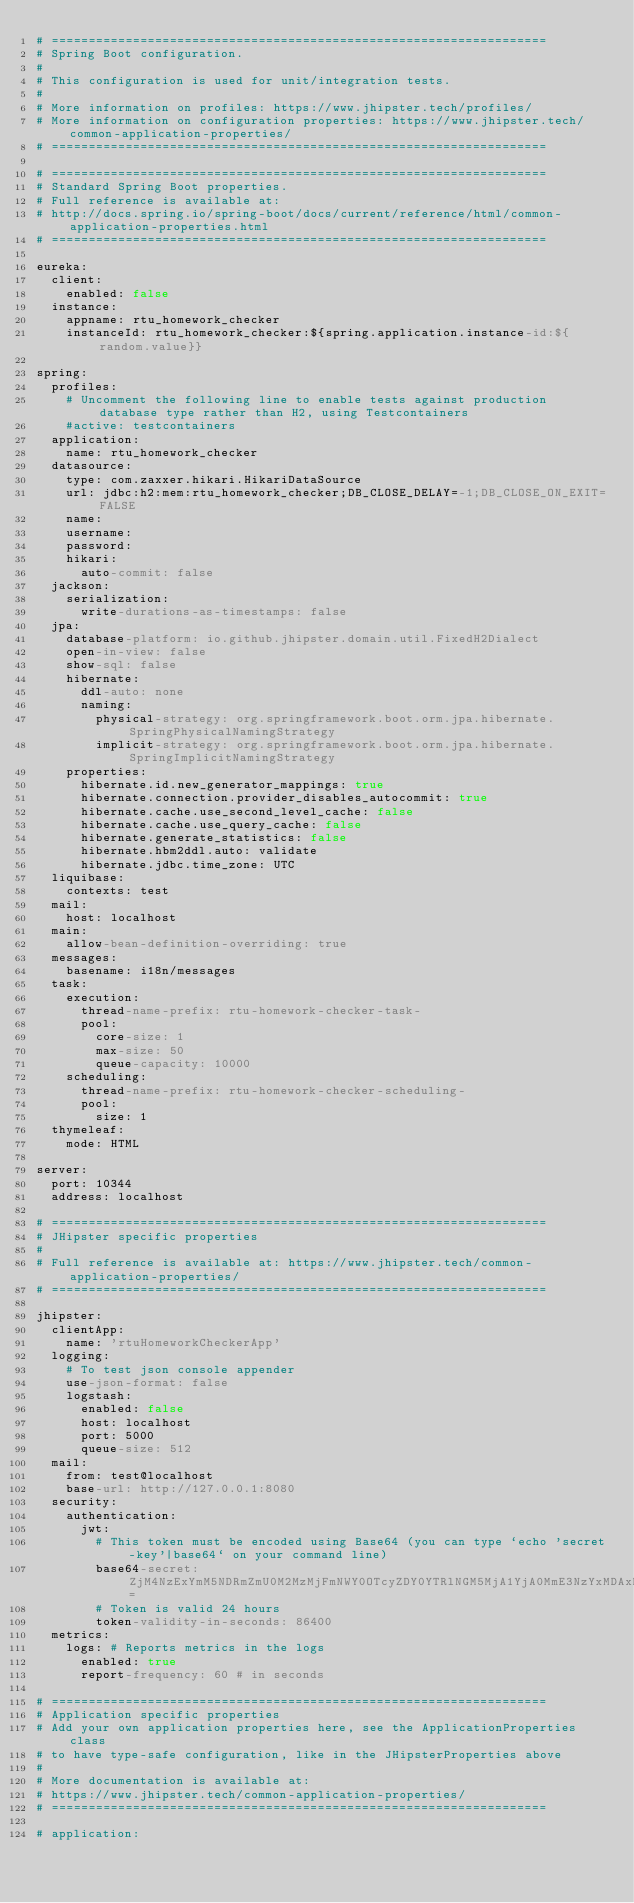<code> <loc_0><loc_0><loc_500><loc_500><_YAML_># ===================================================================
# Spring Boot configuration.
#
# This configuration is used for unit/integration tests.
#
# More information on profiles: https://www.jhipster.tech/profiles/
# More information on configuration properties: https://www.jhipster.tech/common-application-properties/
# ===================================================================

# ===================================================================
# Standard Spring Boot properties.
# Full reference is available at:
# http://docs.spring.io/spring-boot/docs/current/reference/html/common-application-properties.html
# ===================================================================

eureka:
  client:
    enabled: false
  instance:
    appname: rtu_homework_checker
    instanceId: rtu_homework_checker:${spring.application.instance-id:${random.value}}

spring:
  profiles:
    # Uncomment the following line to enable tests against production database type rather than H2, using Testcontainers
    #active: testcontainers
  application:
    name: rtu_homework_checker
  datasource:
    type: com.zaxxer.hikari.HikariDataSource
    url: jdbc:h2:mem:rtu_homework_checker;DB_CLOSE_DELAY=-1;DB_CLOSE_ON_EXIT=FALSE
    name:
    username:
    password:
    hikari:
      auto-commit: false
  jackson:
    serialization:
      write-durations-as-timestamps: false
  jpa:
    database-platform: io.github.jhipster.domain.util.FixedH2Dialect
    open-in-view: false
    show-sql: false
    hibernate:
      ddl-auto: none
      naming:
        physical-strategy: org.springframework.boot.orm.jpa.hibernate.SpringPhysicalNamingStrategy
        implicit-strategy: org.springframework.boot.orm.jpa.hibernate.SpringImplicitNamingStrategy
    properties:
      hibernate.id.new_generator_mappings: true
      hibernate.connection.provider_disables_autocommit: true
      hibernate.cache.use_second_level_cache: false
      hibernate.cache.use_query_cache: false
      hibernate.generate_statistics: false
      hibernate.hbm2ddl.auto: validate
      hibernate.jdbc.time_zone: UTC
  liquibase:
    contexts: test
  mail:
    host: localhost
  main:
    allow-bean-definition-overriding: true
  messages:
    basename: i18n/messages
  task:
    execution:
      thread-name-prefix: rtu-homework-checker-task-
      pool:
        core-size: 1
        max-size: 50
        queue-capacity: 10000
    scheduling:
      thread-name-prefix: rtu-homework-checker-scheduling-
      pool:
        size: 1
  thymeleaf:
    mode: HTML

server:
  port: 10344
  address: localhost

# ===================================================================
# JHipster specific properties
#
# Full reference is available at: https://www.jhipster.tech/common-application-properties/
# ===================================================================

jhipster:
  clientApp:
    name: 'rtuHomeworkCheckerApp'
  logging:
    # To test json console appender
    use-json-format: false
    logstash:
      enabled: false
      host: localhost
      port: 5000
      queue-size: 512
  mail:
    from: test@localhost
    base-url: http://127.0.0.1:8080
  security:
    authentication:
      jwt:
        # This token must be encoded using Base64 (you can type `echo 'secret-key'|base64` on your command line)
        base64-secret: ZjM4NzExYmM5NDRmZmU0M2MzMjFmNWY0OTcyZDY0YTRlNGM5MjA1YjA0MmE3NzYxMDAxMjJmNzU2ZDNlMDA3NzIwZjk1ZTBjMTgxODYyMzJmMTU5MDhlODlmNzE4ODUwNmY5OGNiM2E3OTNlNzM0Mzc1M2UzMWRmZmE5ZDZhNDA=
        # Token is valid 24 hours
        token-validity-in-seconds: 86400
  metrics:
    logs: # Reports metrics in the logs
      enabled: true
      report-frequency: 60 # in seconds

# ===================================================================
# Application specific properties
# Add your own application properties here, see the ApplicationProperties class
# to have type-safe configuration, like in the JHipsterProperties above
#
# More documentation is available at:
# https://www.jhipster.tech/common-application-properties/
# ===================================================================

# application:
</code> 